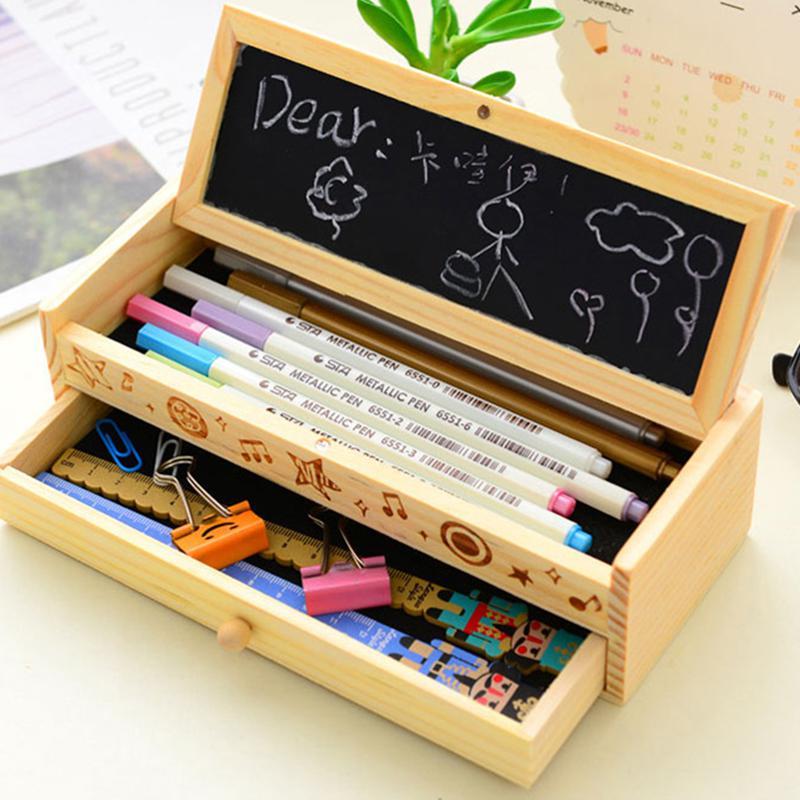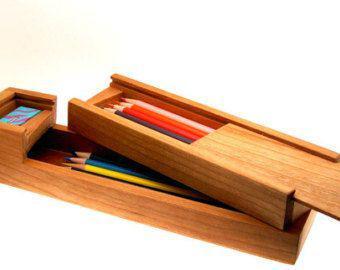The first image is the image on the left, the second image is the image on the right. Evaluate the accuracy of this statement regarding the images: "The case is open in the image on the lef.". Is it true? Answer yes or no. Yes. The first image is the image on the left, the second image is the image on the right. Assess this claim about the two images: "One of the pencil cases pictured has an Eiffel tower imprint.". Correct or not? Answer yes or no. No. 